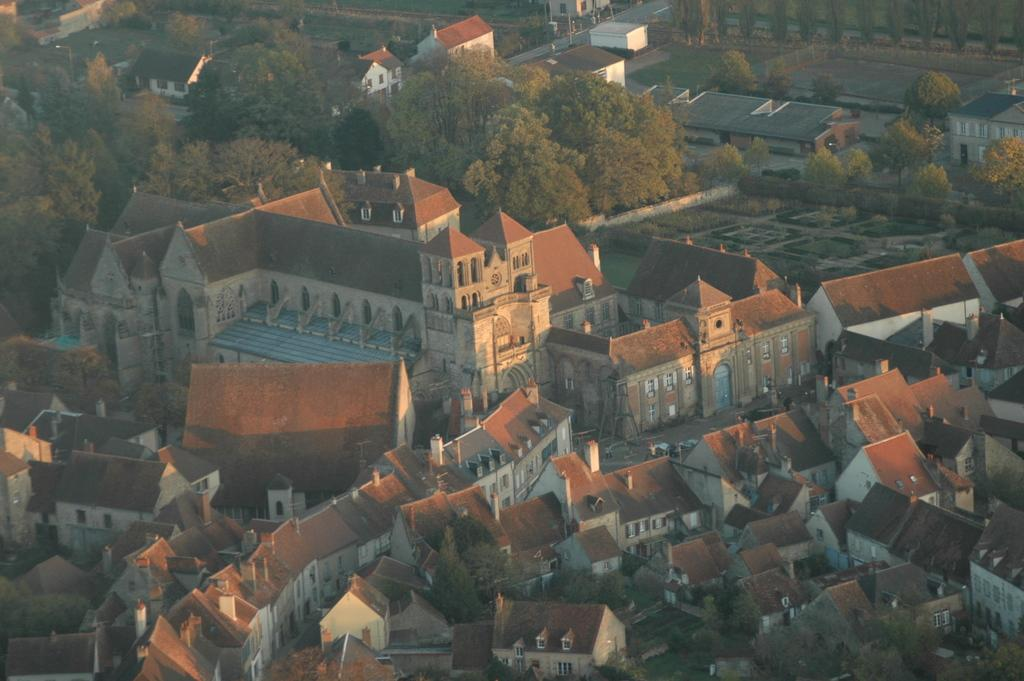What is located in the middle of the picture? There are buildings in the middle of the picture. What can be seen between the buildings in the picture? There are trees between the buildings in the picture. Is there a volcano erupting in the picture? No, there is no volcano present in the picture. What type of structure is visible between the buildings in the picture? There are no additional structures visible between the buildings in the picture; only trees are present. 